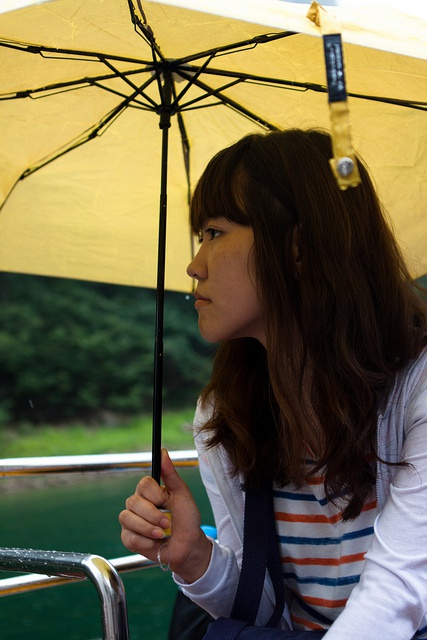Describe the objects in this image and their specific colors. I can see people in ivory, black, gray, and maroon tones, umbrella in ivory, khaki, black, and tan tones, and handbag in ivory, black, navy, and gray tones in this image. 